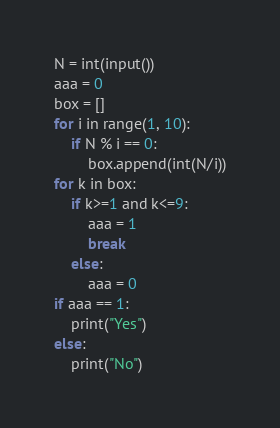<code> <loc_0><loc_0><loc_500><loc_500><_Python_>N = int(input())
aaa = 0 
box = []
for i in range(1, 10):
    if N % i == 0:
        box.append(int(N/i))
for k in box:
    if k>=1 and k<=9:
        aaa = 1 
        break
    else:
        aaa = 0 
if aaa == 1:
    print("Yes")
else:
    print("No")</code> 